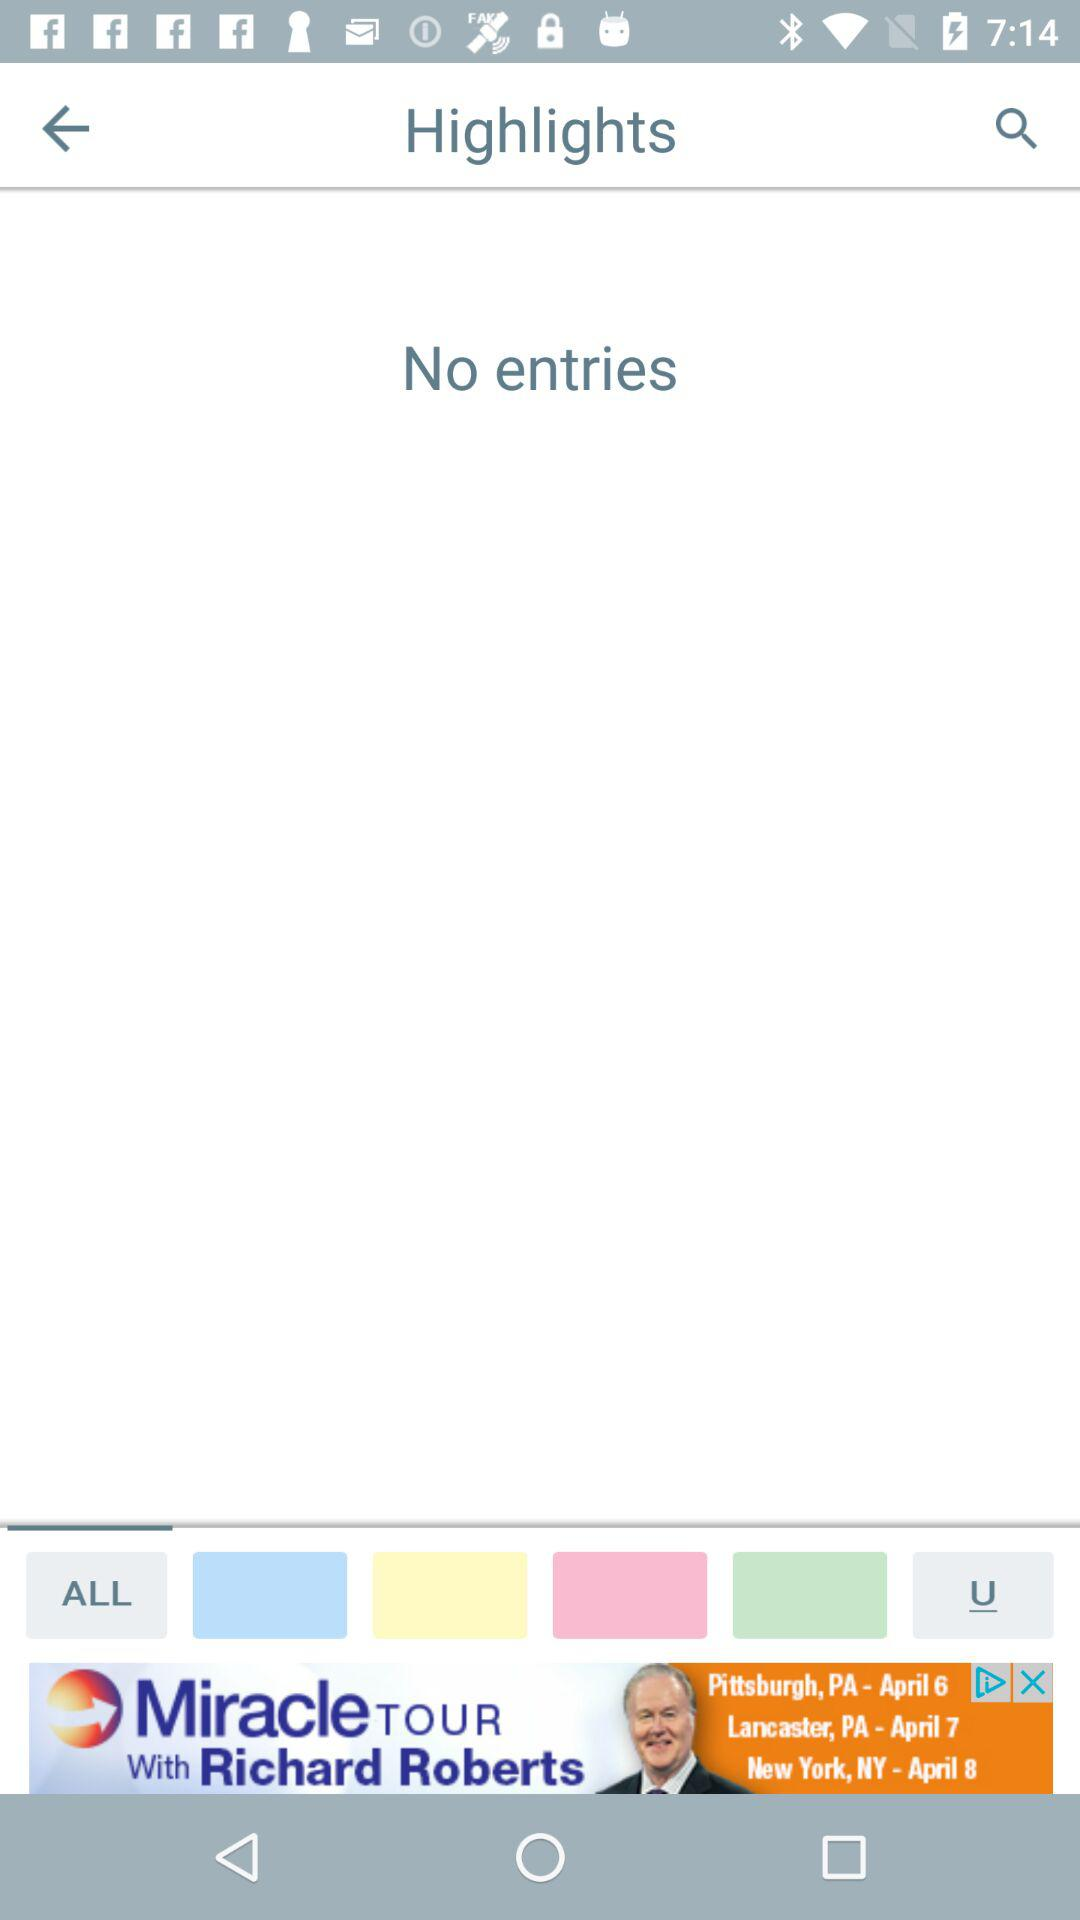How many entries are there? There are no entries. 